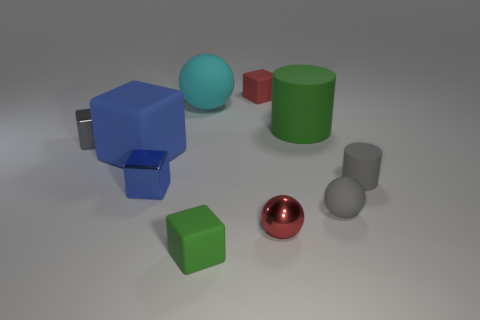What is the size of the cyan object?
Make the answer very short. Large. Does the cyan sphere have the same size as the blue rubber block?
Ensure brevity in your answer.  Yes. There is a tiny metal thing that is both behind the red metallic object and in front of the gray matte cylinder; what is its color?
Make the answer very short. Blue. What number of big objects are the same material as the red cube?
Provide a succinct answer. 3. What number of green matte things are there?
Keep it short and to the point. 2. Do the green cube and the matte sphere that is left of the red matte cube have the same size?
Offer a very short reply. No. What is the material of the gray object on the left side of the tiny rubber cube in front of the blue rubber object?
Your response must be concise. Metal. What is the size of the gray rubber object in front of the cylinder in front of the rubber cylinder behind the tiny gray shiny cube?
Your answer should be compact. Small. Is the shape of the red metal object the same as the cyan object to the right of the large blue object?
Offer a very short reply. Yes. What material is the big cyan ball?
Provide a succinct answer. Rubber. 